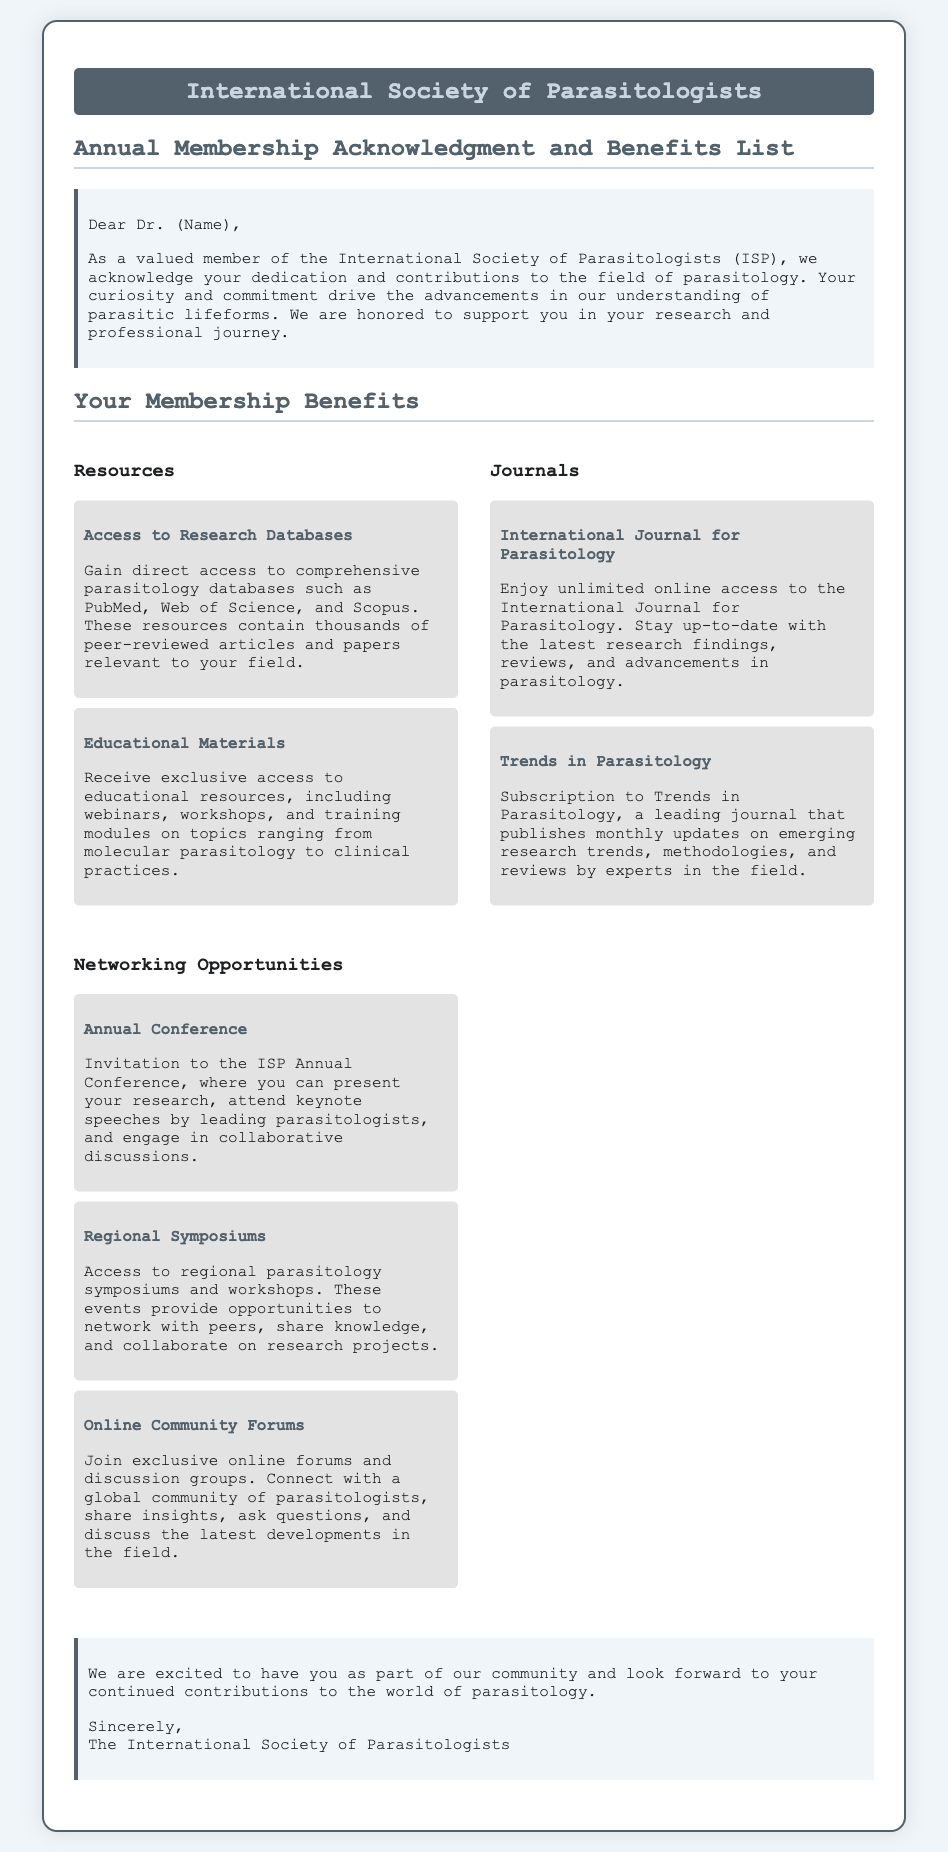what does ISP stand for? ISP refers to the International Society of Parasitologists, as indicated in the document's title.
Answer: International Society of Parasitologists who is addressed in the acknowledgment section? The acknowledgment section directly addresses "Dr. (Name)," indicating it is personalized for members.
Answer: Dr. (Name) how many journals are listed in the document? There are two journals mentioned: the International Journal for Parasitology and Trends in Parasitology.
Answer: 2 what event allows members to present their research? The event specified for presenting research is the ISP Annual Conference.
Answer: ISP Annual Conference what is one type of resource provided to members? The document mentions "Access to Research Databases" as a resource provided to members.
Answer: Access to Research Databases list one networking opportunity mentioned. One networking opportunity mentioned is the "Annual Conference."
Answer: Annual Conference which journal is noted for monthly updates? The journal that publishes monthly updates is "Trends in Parasitology."
Answer: Trends in Parasitology what format do educational materials take? Educational materials include webinars, workshops, and training modules as specified in the resources section.
Answer: webinars, workshops, training modules what type of forums can members join? Members can join "exclusive online forums and discussion groups."
Answer: exclusive online forums and discussion groups 